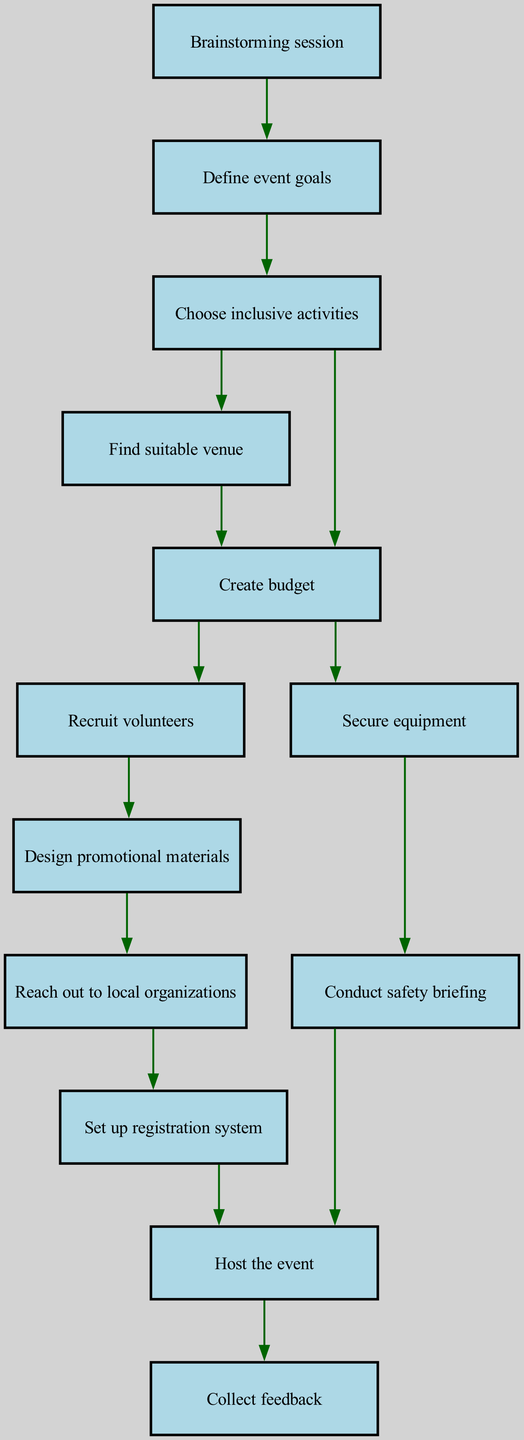What is the first step in organizing the event? The initial step as per the diagram is "Brainstorming session", from which all further steps emanate.
Answer: Brainstorming session How many activities are defined as "Choose inclusive activities"? The diagram shows one directed path from "Define event goals" to "Choose inclusive activities", suggesting there is one main activity at this step.
Answer: One What is the immediate action after creating the budget? Following "Create budget", the next steps are "Recruit volunteers" and "Secure equipment", indicating those actions occur immediately after budget creation.
Answer: Recruit volunteers, Secure equipment Identify the final step in the event organization process. The final action indicated in the flow is "Collect feedback", which leads from "Host the event".
Answer: Collect feedback What two nodes are directly connected to "Choose inclusive activities"? The nodes "Find suitable venue" and "Create budget" are the two subsequent steps directly linked to "Choose inclusive activities" in the directed graph.
Answer: Find suitable venue, Create budget How many edges lead from "Host the event"? There are two edges that lead from "Host the event": one to "Collect feedback" and the other from "Conduct safety briefing".
Answer: Two What are the two actions that directly follow "Set up registration system"? The layout indicates that after "Set up registration system", the immediate action is "Host the event".
Answer: Host the event Which node precedes the "Conduct safety briefing"? The "Secure equipment" node leads directly to "Conduct safety briefing", indicating it is the step immediately before the safety briefing.
Answer: Secure equipment What process involves reaching out to organizations? The "Reach out to local organizations" node follows "Design promotional materials", illustrating that it is part of the outreach process.
Answer: Reach out to local organizations 